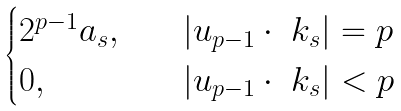Convert formula to latex. <formula><loc_0><loc_0><loc_500><loc_500>\begin{cases} 2 ^ { p - 1 } a _ { s } , \quad & | u _ { p - 1 } \cdot \ k _ { s } | = p \\ 0 , & | u _ { p - 1 } \cdot \ k _ { s } | < p \end{cases}</formula> 